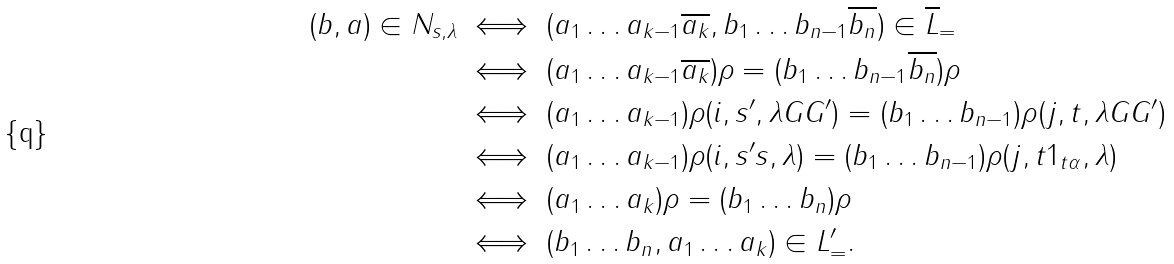<formula> <loc_0><loc_0><loc_500><loc_500>( b , a ) \in N _ { s , \lambda } & \iff ( a _ { 1 } \dots a _ { k - 1 } \overline { a _ { k } } , b _ { 1 } \dots b _ { n - 1 } \overline { b _ { n } } ) \in \overline { L } _ { = } \\ & \iff ( a _ { 1 } \dots a _ { k - 1 } \overline { a _ { k } } ) \rho = ( b _ { 1 } \dots b _ { n - 1 } \overline { b _ { n } } ) \rho \\ & \iff ( a _ { 1 } \dots a _ { k - 1 } ) \rho ( i , s ^ { \prime } , \lambda G G ^ { \prime } ) = ( b _ { 1 } \dots b _ { n - 1 } ) \rho ( j , t , \lambda G G ^ { \prime } ) \\ & \iff ( a _ { 1 } \dots a _ { k - 1 } ) \rho ( i , s ^ { \prime } s , \lambda ) = ( b _ { 1 } \dots b _ { n - 1 } ) \rho ( j , t 1 _ { t \alpha } , \lambda ) \\ & \iff ( a _ { 1 } \dots a _ { k } ) \rho = ( b _ { 1 } \dots b _ { n } ) \rho \\ & \iff ( b _ { 1 } \dots b _ { n } , a _ { 1 } \dots a _ { k } ) \in L _ { = } ^ { \prime } .</formula> 